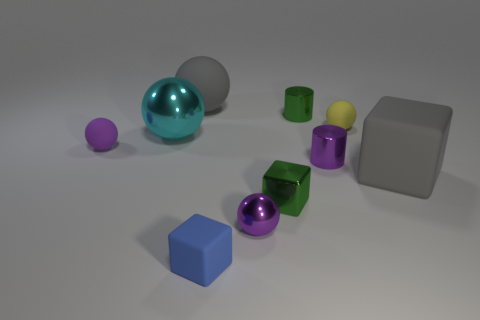Subtract all big gray spheres. How many spheres are left? 4 Subtract all yellow balls. How many balls are left? 4 Subtract all blue balls. Subtract all cyan cylinders. How many balls are left? 5 Subtract all cylinders. How many objects are left? 8 Subtract 1 blue blocks. How many objects are left? 9 Subtract all cubes. Subtract all big brown matte blocks. How many objects are left? 7 Add 2 metallic cylinders. How many metallic cylinders are left? 4 Add 9 large shiny objects. How many large shiny objects exist? 10 